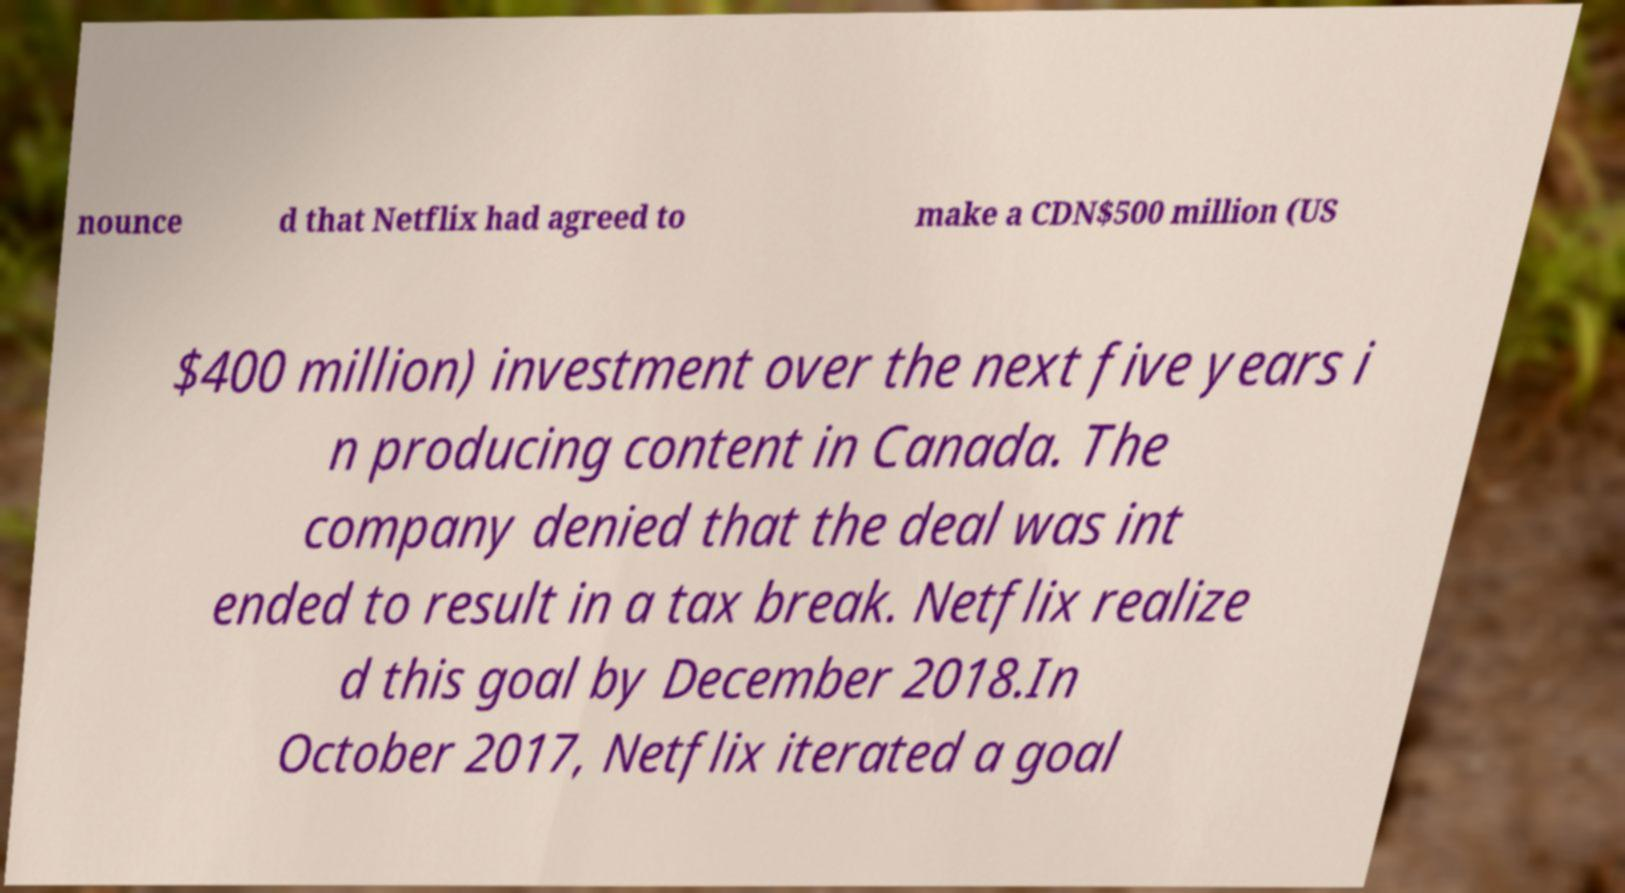Please identify and transcribe the text found in this image. nounce d that Netflix had agreed to make a CDN$500 million (US $400 million) investment over the next five years i n producing content in Canada. The company denied that the deal was int ended to result in a tax break. Netflix realize d this goal by December 2018.In October 2017, Netflix iterated a goal 